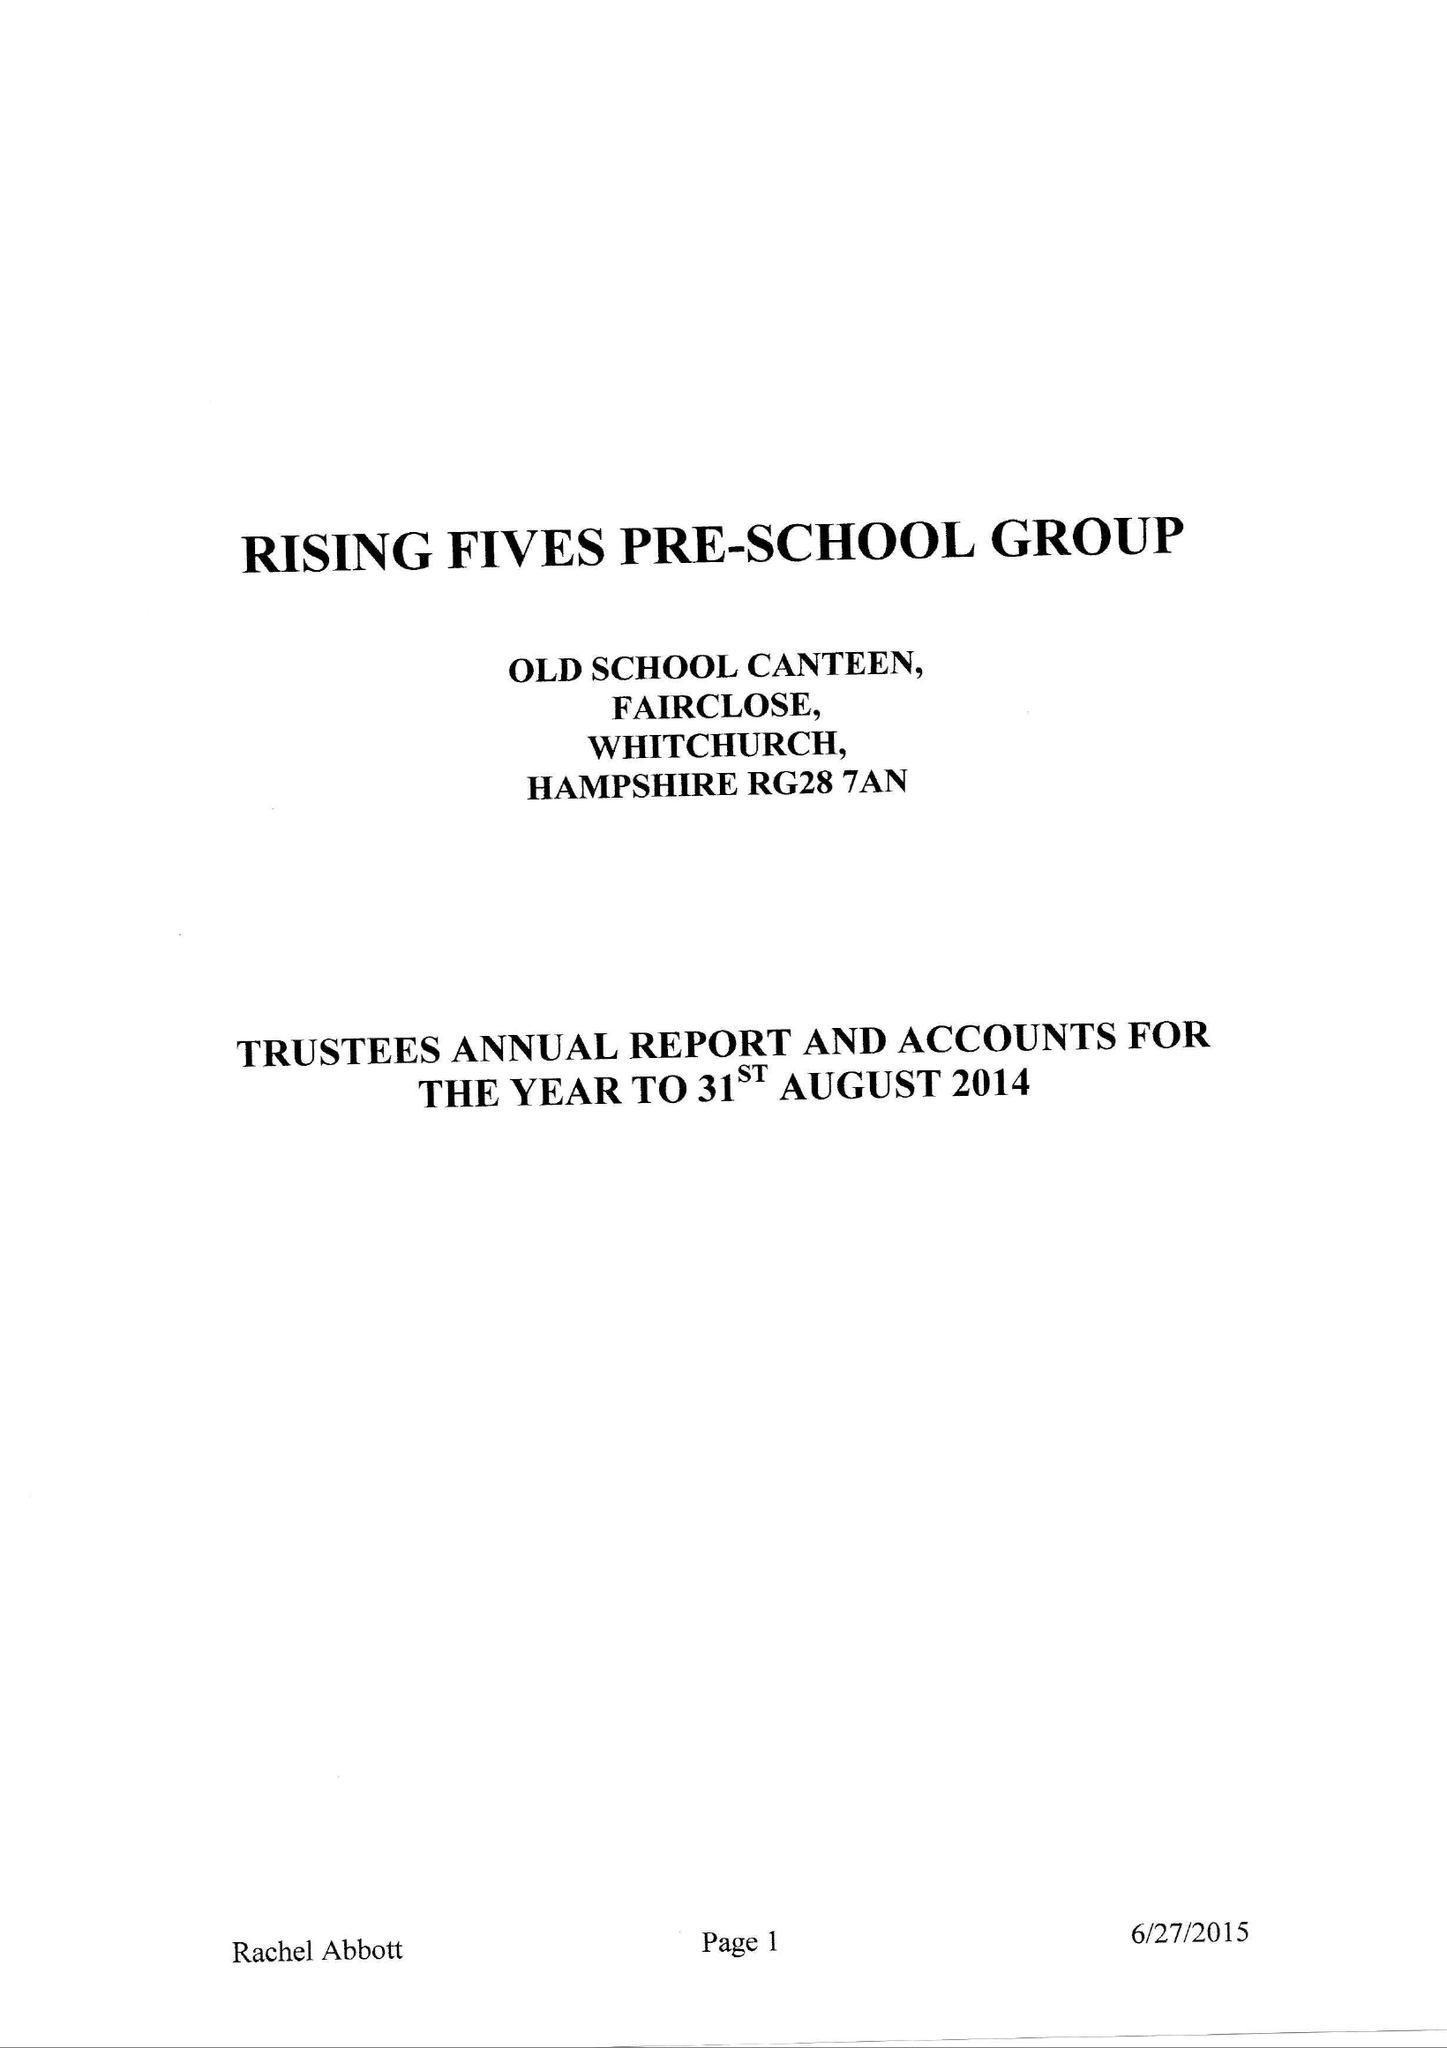What is the value for the charity_number?
Answer the question using a single word or phrase. 270065 